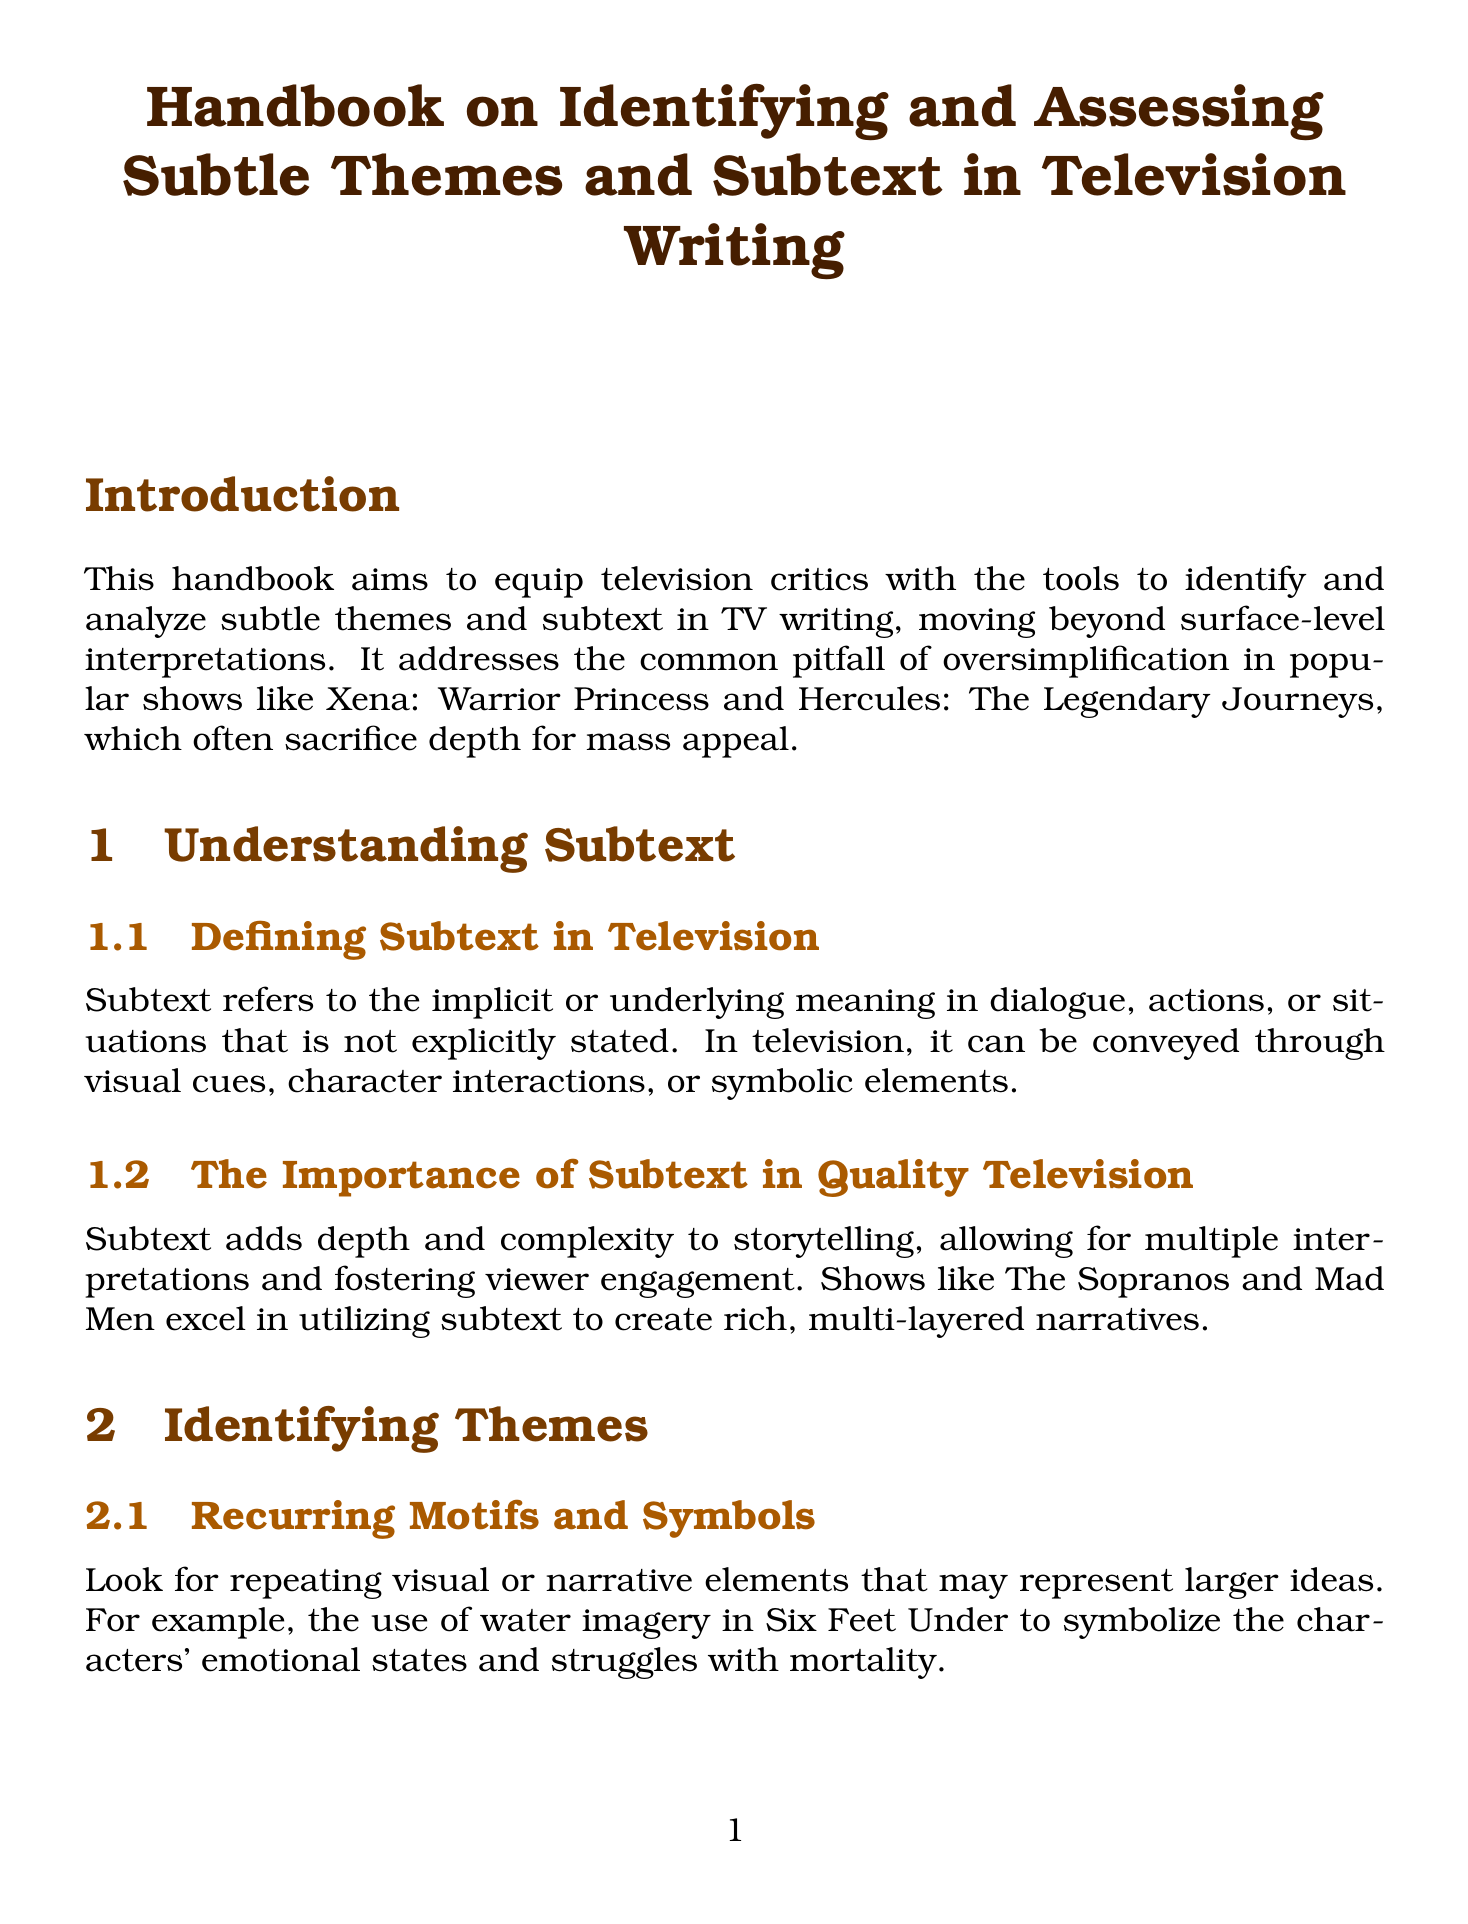What is the title of the handbook? The title is found at the beginning of the document and states the focus on identifying and assessing subtle themes and subtext in television writing.
Answer: Handbook on Identifying and Assessing Subtle Themes and Subtext in Television Writing What show is cited as a comparison to Xena regarding depth? The document discusses contrasting shows to illustrate the difference in depth, specifically mentioning a well-regarded show known for its complexity.
Answer: The Wire How does the handbook define subtext? The definition can be found under the section on subtext, outlining the implicit meanings conveyed in various aspects of storytelling.
Answer: Implicit or underlying meaning Which genre is used to explore complex themes in the show Watchmen? The handbook highlights a specific genre that Watchmen subverts to convey deeper meanings related to its themes.
Answer: Superhero What is one example of a visual storytelling element discussed in the handbook? This information can be extracted from the section on visual storytelling, where examples of symbolic use of visuals are provided.
Answer: Color Symbolism What does the document suggest is often sacrificed for mass appeal in popular shows? The introduction discusses a common pitfall in popular shows, particularly emphasizing what they compromise to gain a wider audience.
Answer: Depth Which show's use of silence is highlighted as a method to convey emotion? The document specifically mentions a show that effectively utilizes non-verbal communication and silence to express complex themes.
Answer: The Leftovers What are critics encouraged to develop in order to provide insightful analysis? The conclusion suggests a specific skill or perspective that critics should cultivate to analyze television writing more effectively.
Answer: A critical eye What theme does Breaking Bad's character transformation represent? The document discusses character arcs and specifies the thematic aspect tied to Walter White's transformation over the series.
Answer: Morality and the corrupting influence of power 